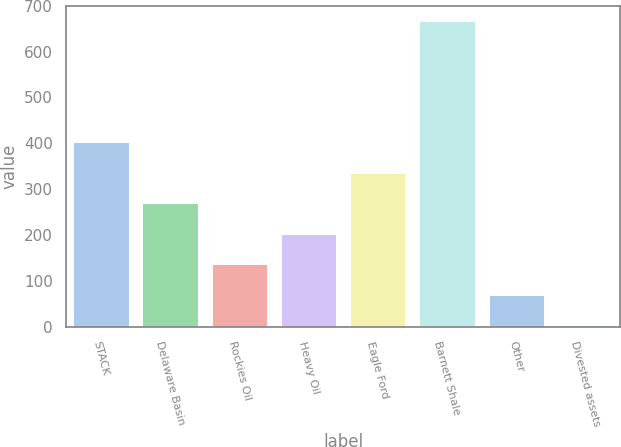<chart> <loc_0><loc_0><loc_500><loc_500><bar_chart><fcel>STACK<fcel>Delaware Basin<fcel>Rockies Oil<fcel>Heavy Oil<fcel>Eagle Ford<fcel>Barnett Shale<fcel>Other<fcel>Divested assets<nl><fcel>401.8<fcel>269.2<fcel>136.6<fcel>202.9<fcel>335.5<fcel>667<fcel>70.3<fcel>4<nl></chart> 